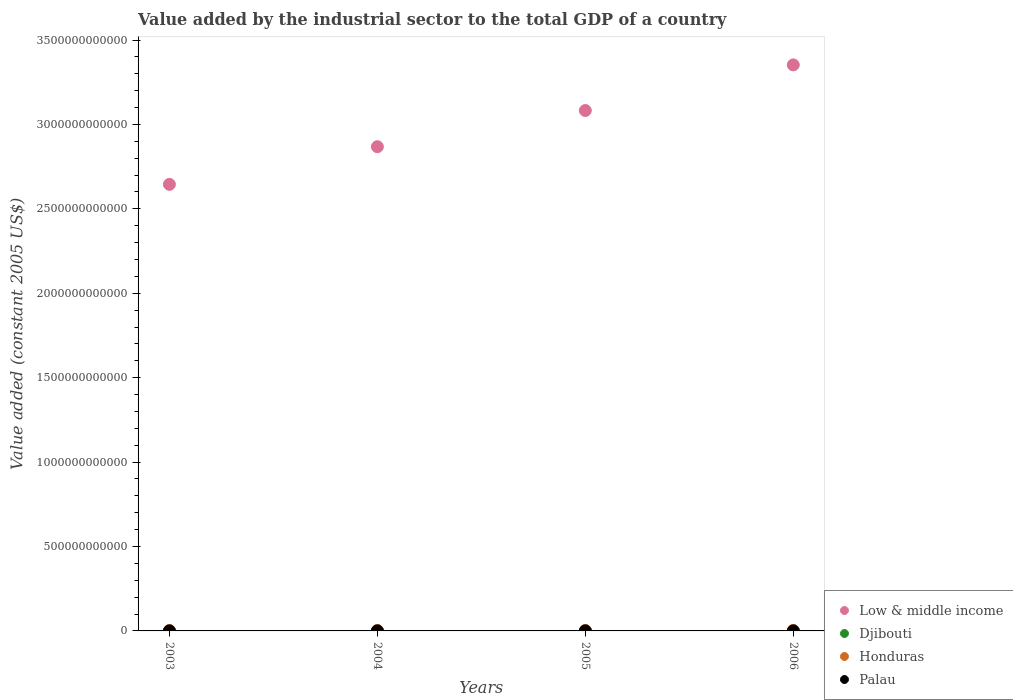How many different coloured dotlines are there?
Offer a very short reply. 4. What is the value added by the industrial sector in Honduras in 2006?
Ensure brevity in your answer.  2.70e+09. Across all years, what is the maximum value added by the industrial sector in Honduras?
Offer a very short reply. 2.70e+09. Across all years, what is the minimum value added by the industrial sector in Low & middle income?
Offer a very short reply. 2.65e+12. In which year was the value added by the industrial sector in Djibouti minimum?
Provide a short and direct response. 2003. What is the total value added by the industrial sector in Palau in the graph?
Your answer should be compact. 1.10e+08. What is the difference between the value added by the industrial sector in Low & middle income in 2003 and that in 2006?
Provide a short and direct response. -7.08e+11. What is the difference between the value added by the industrial sector in Honduras in 2006 and the value added by the industrial sector in Low & middle income in 2003?
Make the answer very short. -2.64e+12. What is the average value added by the industrial sector in Low & middle income per year?
Offer a terse response. 2.99e+12. In the year 2005, what is the difference between the value added by the industrial sector in Honduras and value added by the industrial sector in Palau?
Offer a terse response. 2.51e+09. In how many years, is the value added by the industrial sector in Palau greater than 1100000000000 US$?
Your answer should be compact. 0. What is the ratio of the value added by the industrial sector in Low & middle income in 2003 to that in 2005?
Offer a terse response. 0.86. What is the difference between the highest and the second highest value added by the industrial sector in Djibouti?
Your answer should be compact. 3.85e+06. What is the difference between the highest and the lowest value added by the industrial sector in Honduras?
Ensure brevity in your answer.  4.21e+08. Is it the case that in every year, the sum of the value added by the industrial sector in Palau and value added by the industrial sector in Djibouti  is greater than the sum of value added by the industrial sector in Honduras and value added by the industrial sector in Low & middle income?
Your answer should be compact. Yes. How many years are there in the graph?
Offer a terse response. 4. What is the difference between two consecutive major ticks on the Y-axis?
Provide a short and direct response. 5.00e+11. Are the values on the major ticks of Y-axis written in scientific E-notation?
Provide a succinct answer. No. Does the graph contain grids?
Ensure brevity in your answer.  No. How are the legend labels stacked?
Offer a terse response. Vertical. What is the title of the graph?
Make the answer very short. Value added by the industrial sector to the total GDP of a country. What is the label or title of the Y-axis?
Make the answer very short. Value added (constant 2005 US$). What is the Value added (constant 2005 US$) of Low & middle income in 2003?
Your response must be concise. 2.65e+12. What is the Value added (constant 2005 US$) of Djibouti in 2003?
Provide a succinct answer. 9.26e+07. What is the Value added (constant 2005 US$) in Honduras in 2003?
Provide a short and direct response. 2.28e+09. What is the Value added (constant 2005 US$) in Palau in 2003?
Give a very brief answer. 2.77e+07. What is the Value added (constant 2005 US$) in Low & middle income in 2004?
Your answer should be compact. 2.87e+12. What is the Value added (constant 2005 US$) in Djibouti in 2004?
Give a very brief answer. 9.94e+07. What is the Value added (constant 2005 US$) of Honduras in 2004?
Provide a succinct answer. 2.36e+09. What is the Value added (constant 2005 US$) in Palau in 2004?
Make the answer very short. 2.68e+07. What is the Value added (constant 2005 US$) of Low & middle income in 2005?
Your answer should be very brief. 3.08e+12. What is the Value added (constant 2005 US$) in Djibouti in 2005?
Offer a terse response. 1.05e+08. What is the Value added (constant 2005 US$) in Honduras in 2005?
Make the answer very short. 2.54e+09. What is the Value added (constant 2005 US$) of Palau in 2005?
Make the answer very short. 2.92e+07. What is the Value added (constant 2005 US$) of Low & middle income in 2006?
Your response must be concise. 3.35e+12. What is the Value added (constant 2005 US$) in Djibouti in 2006?
Your answer should be compact. 1.09e+08. What is the Value added (constant 2005 US$) in Honduras in 2006?
Your answer should be very brief. 2.70e+09. What is the Value added (constant 2005 US$) in Palau in 2006?
Ensure brevity in your answer.  2.58e+07. Across all years, what is the maximum Value added (constant 2005 US$) in Low & middle income?
Your answer should be very brief. 3.35e+12. Across all years, what is the maximum Value added (constant 2005 US$) in Djibouti?
Give a very brief answer. 1.09e+08. Across all years, what is the maximum Value added (constant 2005 US$) in Honduras?
Ensure brevity in your answer.  2.70e+09. Across all years, what is the maximum Value added (constant 2005 US$) of Palau?
Your answer should be compact. 2.92e+07. Across all years, what is the minimum Value added (constant 2005 US$) in Low & middle income?
Ensure brevity in your answer.  2.65e+12. Across all years, what is the minimum Value added (constant 2005 US$) in Djibouti?
Keep it short and to the point. 9.26e+07. Across all years, what is the minimum Value added (constant 2005 US$) of Honduras?
Ensure brevity in your answer.  2.28e+09. Across all years, what is the minimum Value added (constant 2005 US$) of Palau?
Your answer should be very brief. 2.58e+07. What is the total Value added (constant 2005 US$) in Low & middle income in the graph?
Provide a short and direct response. 1.19e+13. What is the total Value added (constant 2005 US$) in Djibouti in the graph?
Provide a short and direct response. 4.05e+08. What is the total Value added (constant 2005 US$) in Honduras in the graph?
Your answer should be compact. 9.87e+09. What is the total Value added (constant 2005 US$) of Palau in the graph?
Ensure brevity in your answer.  1.10e+08. What is the difference between the Value added (constant 2005 US$) in Low & middle income in 2003 and that in 2004?
Keep it short and to the point. -2.23e+11. What is the difference between the Value added (constant 2005 US$) of Djibouti in 2003 and that in 2004?
Keep it short and to the point. -6.79e+06. What is the difference between the Value added (constant 2005 US$) of Honduras in 2003 and that in 2004?
Keep it short and to the point. -7.98e+07. What is the difference between the Value added (constant 2005 US$) in Palau in 2003 and that in 2004?
Your answer should be compact. 8.75e+05. What is the difference between the Value added (constant 2005 US$) in Low & middle income in 2003 and that in 2005?
Your answer should be compact. -4.37e+11. What is the difference between the Value added (constant 2005 US$) of Djibouti in 2003 and that in 2005?
Offer a terse response. -1.21e+07. What is the difference between the Value added (constant 2005 US$) of Honduras in 2003 and that in 2005?
Your answer should be very brief. -2.60e+08. What is the difference between the Value added (constant 2005 US$) of Palau in 2003 and that in 2005?
Provide a short and direct response. -1.58e+06. What is the difference between the Value added (constant 2005 US$) in Low & middle income in 2003 and that in 2006?
Give a very brief answer. -7.08e+11. What is the difference between the Value added (constant 2005 US$) in Djibouti in 2003 and that in 2006?
Make the answer very short. -1.60e+07. What is the difference between the Value added (constant 2005 US$) in Honduras in 2003 and that in 2006?
Provide a short and direct response. -4.21e+08. What is the difference between the Value added (constant 2005 US$) in Palau in 2003 and that in 2006?
Give a very brief answer. 1.82e+06. What is the difference between the Value added (constant 2005 US$) of Low & middle income in 2004 and that in 2005?
Provide a succinct answer. -2.14e+11. What is the difference between the Value added (constant 2005 US$) of Djibouti in 2004 and that in 2005?
Your answer should be very brief. -5.33e+06. What is the difference between the Value added (constant 2005 US$) in Honduras in 2004 and that in 2005?
Provide a short and direct response. -1.80e+08. What is the difference between the Value added (constant 2005 US$) of Palau in 2004 and that in 2005?
Offer a terse response. -2.46e+06. What is the difference between the Value added (constant 2005 US$) of Low & middle income in 2004 and that in 2006?
Provide a succinct answer. -4.85e+11. What is the difference between the Value added (constant 2005 US$) of Djibouti in 2004 and that in 2006?
Provide a short and direct response. -9.18e+06. What is the difference between the Value added (constant 2005 US$) of Honduras in 2004 and that in 2006?
Provide a succinct answer. -3.41e+08. What is the difference between the Value added (constant 2005 US$) in Palau in 2004 and that in 2006?
Give a very brief answer. 9.42e+05. What is the difference between the Value added (constant 2005 US$) in Low & middle income in 2005 and that in 2006?
Offer a very short reply. -2.70e+11. What is the difference between the Value added (constant 2005 US$) of Djibouti in 2005 and that in 2006?
Ensure brevity in your answer.  -3.85e+06. What is the difference between the Value added (constant 2005 US$) in Honduras in 2005 and that in 2006?
Give a very brief answer. -1.61e+08. What is the difference between the Value added (constant 2005 US$) of Palau in 2005 and that in 2006?
Your response must be concise. 3.40e+06. What is the difference between the Value added (constant 2005 US$) in Low & middle income in 2003 and the Value added (constant 2005 US$) in Djibouti in 2004?
Give a very brief answer. 2.65e+12. What is the difference between the Value added (constant 2005 US$) in Low & middle income in 2003 and the Value added (constant 2005 US$) in Honduras in 2004?
Ensure brevity in your answer.  2.64e+12. What is the difference between the Value added (constant 2005 US$) in Low & middle income in 2003 and the Value added (constant 2005 US$) in Palau in 2004?
Provide a succinct answer. 2.65e+12. What is the difference between the Value added (constant 2005 US$) of Djibouti in 2003 and the Value added (constant 2005 US$) of Honduras in 2004?
Ensure brevity in your answer.  -2.27e+09. What is the difference between the Value added (constant 2005 US$) in Djibouti in 2003 and the Value added (constant 2005 US$) in Palau in 2004?
Your answer should be very brief. 6.58e+07. What is the difference between the Value added (constant 2005 US$) of Honduras in 2003 and the Value added (constant 2005 US$) of Palau in 2004?
Keep it short and to the point. 2.25e+09. What is the difference between the Value added (constant 2005 US$) of Low & middle income in 2003 and the Value added (constant 2005 US$) of Djibouti in 2005?
Your answer should be compact. 2.65e+12. What is the difference between the Value added (constant 2005 US$) of Low & middle income in 2003 and the Value added (constant 2005 US$) of Honduras in 2005?
Your answer should be very brief. 2.64e+12. What is the difference between the Value added (constant 2005 US$) in Low & middle income in 2003 and the Value added (constant 2005 US$) in Palau in 2005?
Provide a short and direct response. 2.65e+12. What is the difference between the Value added (constant 2005 US$) in Djibouti in 2003 and the Value added (constant 2005 US$) in Honduras in 2005?
Provide a short and direct response. -2.45e+09. What is the difference between the Value added (constant 2005 US$) in Djibouti in 2003 and the Value added (constant 2005 US$) in Palau in 2005?
Make the answer very short. 6.34e+07. What is the difference between the Value added (constant 2005 US$) of Honduras in 2003 and the Value added (constant 2005 US$) of Palau in 2005?
Offer a very short reply. 2.25e+09. What is the difference between the Value added (constant 2005 US$) of Low & middle income in 2003 and the Value added (constant 2005 US$) of Djibouti in 2006?
Keep it short and to the point. 2.65e+12. What is the difference between the Value added (constant 2005 US$) in Low & middle income in 2003 and the Value added (constant 2005 US$) in Honduras in 2006?
Ensure brevity in your answer.  2.64e+12. What is the difference between the Value added (constant 2005 US$) in Low & middle income in 2003 and the Value added (constant 2005 US$) in Palau in 2006?
Give a very brief answer. 2.65e+12. What is the difference between the Value added (constant 2005 US$) in Djibouti in 2003 and the Value added (constant 2005 US$) in Honduras in 2006?
Your response must be concise. -2.61e+09. What is the difference between the Value added (constant 2005 US$) in Djibouti in 2003 and the Value added (constant 2005 US$) in Palau in 2006?
Give a very brief answer. 6.68e+07. What is the difference between the Value added (constant 2005 US$) in Honduras in 2003 and the Value added (constant 2005 US$) in Palau in 2006?
Make the answer very short. 2.25e+09. What is the difference between the Value added (constant 2005 US$) in Low & middle income in 2004 and the Value added (constant 2005 US$) in Djibouti in 2005?
Ensure brevity in your answer.  2.87e+12. What is the difference between the Value added (constant 2005 US$) in Low & middle income in 2004 and the Value added (constant 2005 US$) in Honduras in 2005?
Provide a succinct answer. 2.87e+12. What is the difference between the Value added (constant 2005 US$) in Low & middle income in 2004 and the Value added (constant 2005 US$) in Palau in 2005?
Give a very brief answer. 2.87e+12. What is the difference between the Value added (constant 2005 US$) in Djibouti in 2004 and the Value added (constant 2005 US$) in Honduras in 2005?
Ensure brevity in your answer.  -2.44e+09. What is the difference between the Value added (constant 2005 US$) of Djibouti in 2004 and the Value added (constant 2005 US$) of Palau in 2005?
Your answer should be compact. 7.01e+07. What is the difference between the Value added (constant 2005 US$) of Honduras in 2004 and the Value added (constant 2005 US$) of Palau in 2005?
Make the answer very short. 2.33e+09. What is the difference between the Value added (constant 2005 US$) in Low & middle income in 2004 and the Value added (constant 2005 US$) in Djibouti in 2006?
Your answer should be very brief. 2.87e+12. What is the difference between the Value added (constant 2005 US$) of Low & middle income in 2004 and the Value added (constant 2005 US$) of Honduras in 2006?
Make the answer very short. 2.87e+12. What is the difference between the Value added (constant 2005 US$) of Low & middle income in 2004 and the Value added (constant 2005 US$) of Palau in 2006?
Your answer should be very brief. 2.87e+12. What is the difference between the Value added (constant 2005 US$) in Djibouti in 2004 and the Value added (constant 2005 US$) in Honduras in 2006?
Your answer should be compact. -2.60e+09. What is the difference between the Value added (constant 2005 US$) of Djibouti in 2004 and the Value added (constant 2005 US$) of Palau in 2006?
Offer a terse response. 7.35e+07. What is the difference between the Value added (constant 2005 US$) in Honduras in 2004 and the Value added (constant 2005 US$) in Palau in 2006?
Your answer should be very brief. 2.33e+09. What is the difference between the Value added (constant 2005 US$) of Low & middle income in 2005 and the Value added (constant 2005 US$) of Djibouti in 2006?
Offer a very short reply. 3.08e+12. What is the difference between the Value added (constant 2005 US$) of Low & middle income in 2005 and the Value added (constant 2005 US$) of Honduras in 2006?
Ensure brevity in your answer.  3.08e+12. What is the difference between the Value added (constant 2005 US$) in Low & middle income in 2005 and the Value added (constant 2005 US$) in Palau in 2006?
Offer a very short reply. 3.08e+12. What is the difference between the Value added (constant 2005 US$) of Djibouti in 2005 and the Value added (constant 2005 US$) of Honduras in 2006?
Your answer should be compact. -2.59e+09. What is the difference between the Value added (constant 2005 US$) of Djibouti in 2005 and the Value added (constant 2005 US$) of Palau in 2006?
Your answer should be very brief. 7.89e+07. What is the difference between the Value added (constant 2005 US$) of Honduras in 2005 and the Value added (constant 2005 US$) of Palau in 2006?
Your response must be concise. 2.51e+09. What is the average Value added (constant 2005 US$) of Low & middle income per year?
Make the answer very short. 2.99e+12. What is the average Value added (constant 2005 US$) of Djibouti per year?
Offer a very short reply. 1.01e+08. What is the average Value added (constant 2005 US$) in Honduras per year?
Your answer should be very brief. 2.47e+09. What is the average Value added (constant 2005 US$) of Palau per year?
Ensure brevity in your answer.  2.74e+07. In the year 2003, what is the difference between the Value added (constant 2005 US$) in Low & middle income and Value added (constant 2005 US$) in Djibouti?
Your answer should be very brief. 2.65e+12. In the year 2003, what is the difference between the Value added (constant 2005 US$) in Low & middle income and Value added (constant 2005 US$) in Honduras?
Your response must be concise. 2.64e+12. In the year 2003, what is the difference between the Value added (constant 2005 US$) in Low & middle income and Value added (constant 2005 US$) in Palau?
Provide a succinct answer. 2.65e+12. In the year 2003, what is the difference between the Value added (constant 2005 US$) in Djibouti and Value added (constant 2005 US$) in Honduras?
Provide a short and direct response. -2.19e+09. In the year 2003, what is the difference between the Value added (constant 2005 US$) in Djibouti and Value added (constant 2005 US$) in Palau?
Your answer should be compact. 6.49e+07. In the year 2003, what is the difference between the Value added (constant 2005 US$) in Honduras and Value added (constant 2005 US$) in Palau?
Offer a terse response. 2.25e+09. In the year 2004, what is the difference between the Value added (constant 2005 US$) of Low & middle income and Value added (constant 2005 US$) of Djibouti?
Give a very brief answer. 2.87e+12. In the year 2004, what is the difference between the Value added (constant 2005 US$) of Low & middle income and Value added (constant 2005 US$) of Honduras?
Your response must be concise. 2.87e+12. In the year 2004, what is the difference between the Value added (constant 2005 US$) of Low & middle income and Value added (constant 2005 US$) of Palau?
Offer a very short reply. 2.87e+12. In the year 2004, what is the difference between the Value added (constant 2005 US$) in Djibouti and Value added (constant 2005 US$) in Honduras?
Give a very brief answer. -2.26e+09. In the year 2004, what is the difference between the Value added (constant 2005 US$) in Djibouti and Value added (constant 2005 US$) in Palau?
Your answer should be compact. 7.26e+07. In the year 2004, what is the difference between the Value added (constant 2005 US$) in Honduras and Value added (constant 2005 US$) in Palau?
Your answer should be very brief. 2.33e+09. In the year 2005, what is the difference between the Value added (constant 2005 US$) in Low & middle income and Value added (constant 2005 US$) in Djibouti?
Offer a terse response. 3.08e+12. In the year 2005, what is the difference between the Value added (constant 2005 US$) in Low & middle income and Value added (constant 2005 US$) in Honduras?
Make the answer very short. 3.08e+12. In the year 2005, what is the difference between the Value added (constant 2005 US$) of Low & middle income and Value added (constant 2005 US$) of Palau?
Give a very brief answer. 3.08e+12. In the year 2005, what is the difference between the Value added (constant 2005 US$) in Djibouti and Value added (constant 2005 US$) in Honduras?
Keep it short and to the point. -2.43e+09. In the year 2005, what is the difference between the Value added (constant 2005 US$) in Djibouti and Value added (constant 2005 US$) in Palau?
Your response must be concise. 7.55e+07. In the year 2005, what is the difference between the Value added (constant 2005 US$) in Honduras and Value added (constant 2005 US$) in Palau?
Make the answer very short. 2.51e+09. In the year 2006, what is the difference between the Value added (constant 2005 US$) in Low & middle income and Value added (constant 2005 US$) in Djibouti?
Offer a terse response. 3.35e+12. In the year 2006, what is the difference between the Value added (constant 2005 US$) of Low & middle income and Value added (constant 2005 US$) of Honduras?
Your answer should be compact. 3.35e+12. In the year 2006, what is the difference between the Value added (constant 2005 US$) of Low & middle income and Value added (constant 2005 US$) of Palau?
Your answer should be compact. 3.35e+12. In the year 2006, what is the difference between the Value added (constant 2005 US$) of Djibouti and Value added (constant 2005 US$) of Honduras?
Provide a short and direct response. -2.59e+09. In the year 2006, what is the difference between the Value added (constant 2005 US$) in Djibouti and Value added (constant 2005 US$) in Palau?
Offer a very short reply. 8.27e+07. In the year 2006, what is the difference between the Value added (constant 2005 US$) of Honduras and Value added (constant 2005 US$) of Palau?
Make the answer very short. 2.67e+09. What is the ratio of the Value added (constant 2005 US$) of Low & middle income in 2003 to that in 2004?
Your answer should be compact. 0.92. What is the ratio of the Value added (constant 2005 US$) in Djibouti in 2003 to that in 2004?
Give a very brief answer. 0.93. What is the ratio of the Value added (constant 2005 US$) of Honduras in 2003 to that in 2004?
Provide a succinct answer. 0.97. What is the ratio of the Value added (constant 2005 US$) of Palau in 2003 to that in 2004?
Your answer should be compact. 1.03. What is the ratio of the Value added (constant 2005 US$) in Low & middle income in 2003 to that in 2005?
Provide a succinct answer. 0.86. What is the ratio of the Value added (constant 2005 US$) of Djibouti in 2003 to that in 2005?
Offer a very short reply. 0.88. What is the ratio of the Value added (constant 2005 US$) in Honduras in 2003 to that in 2005?
Ensure brevity in your answer.  0.9. What is the ratio of the Value added (constant 2005 US$) of Palau in 2003 to that in 2005?
Your answer should be compact. 0.95. What is the ratio of the Value added (constant 2005 US$) of Low & middle income in 2003 to that in 2006?
Provide a succinct answer. 0.79. What is the ratio of the Value added (constant 2005 US$) in Djibouti in 2003 to that in 2006?
Provide a succinct answer. 0.85. What is the ratio of the Value added (constant 2005 US$) of Honduras in 2003 to that in 2006?
Keep it short and to the point. 0.84. What is the ratio of the Value added (constant 2005 US$) of Palau in 2003 to that in 2006?
Provide a succinct answer. 1.07. What is the ratio of the Value added (constant 2005 US$) in Low & middle income in 2004 to that in 2005?
Provide a short and direct response. 0.93. What is the ratio of the Value added (constant 2005 US$) in Djibouti in 2004 to that in 2005?
Offer a terse response. 0.95. What is the ratio of the Value added (constant 2005 US$) of Honduras in 2004 to that in 2005?
Give a very brief answer. 0.93. What is the ratio of the Value added (constant 2005 US$) of Palau in 2004 to that in 2005?
Ensure brevity in your answer.  0.92. What is the ratio of the Value added (constant 2005 US$) in Low & middle income in 2004 to that in 2006?
Ensure brevity in your answer.  0.86. What is the ratio of the Value added (constant 2005 US$) in Djibouti in 2004 to that in 2006?
Offer a terse response. 0.92. What is the ratio of the Value added (constant 2005 US$) of Honduras in 2004 to that in 2006?
Your answer should be very brief. 0.87. What is the ratio of the Value added (constant 2005 US$) in Palau in 2004 to that in 2006?
Provide a short and direct response. 1.04. What is the ratio of the Value added (constant 2005 US$) in Low & middle income in 2005 to that in 2006?
Keep it short and to the point. 0.92. What is the ratio of the Value added (constant 2005 US$) in Djibouti in 2005 to that in 2006?
Give a very brief answer. 0.96. What is the ratio of the Value added (constant 2005 US$) of Honduras in 2005 to that in 2006?
Ensure brevity in your answer.  0.94. What is the ratio of the Value added (constant 2005 US$) of Palau in 2005 to that in 2006?
Your answer should be compact. 1.13. What is the difference between the highest and the second highest Value added (constant 2005 US$) in Low & middle income?
Your answer should be compact. 2.70e+11. What is the difference between the highest and the second highest Value added (constant 2005 US$) of Djibouti?
Offer a very short reply. 3.85e+06. What is the difference between the highest and the second highest Value added (constant 2005 US$) of Honduras?
Make the answer very short. 1.61e+08. What is the difference between the highest and the second highest Value added (constant 2005 US$) in Palau?
Offer a terse response. 1.58e+06. What is the difference between the highest and the lowest Value added (constant 2005 US$) of Low & middle income?
Provide a short and direct response. 7.08e+11. What is the difference between the highest and the lowest Value added (constant 2005 US$) in Djibouti?
Your response must be concise. 1.60e+07. What is the difference between the highest and the lowest Value added (constant 2005 US$) in Honduras?
Provide a succinct answer. 4.21e+08. What is the difference between the highest and the lowest Value added (constant 2005 US$) of Palau?
Ensure brevity in your answer.  3.40e+06. 